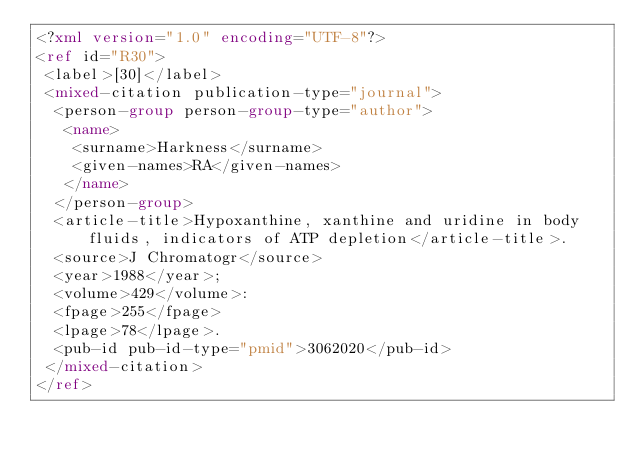Convert code to text. <code><loc_0><loc_0><loc_500><loc_500><_XML_><?xml version="1.0" encoding="UTF-8"?>
<ref id="R30">
 <label>[30]</label>
 <mixed-citation publication-type="journal">
  <person-group person-group-type="author">
   <name>
    <surname>Harkness</surname>
    <given-names>RA</given-names>
   </name>
  </person-group>
  <article-title>Hypoxanthine, xanthine and uridine in body fluids, indicators of ATP depletion</article-title>. 
  <source>J Chromatogr</source>
  <year>1988</year>;
  <volume>429</volume>:
  <fpage>255</fpage>
  <lpage>78</lpage>.
  <pub-id pub-id-type="pmid">3062020</pub-id>
 </mixed-citation>
</ref>
</code> 